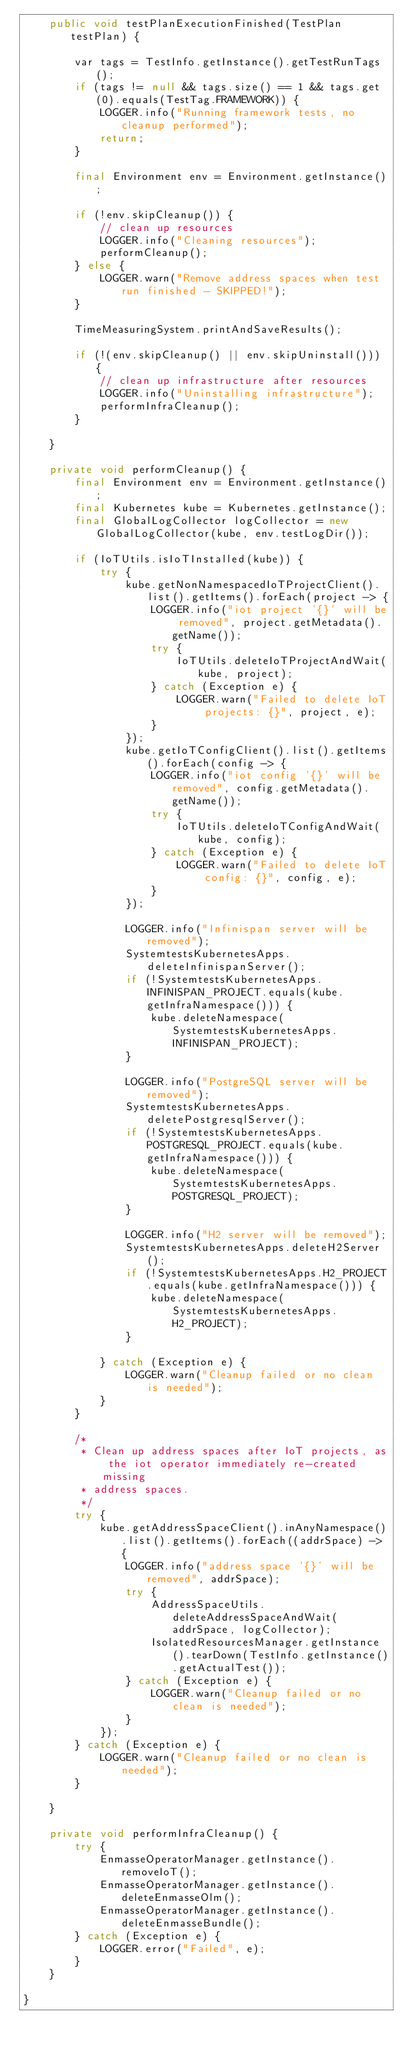<code> <loc_0><loc_0><loc_500><loc_500><_Java_>    public void testPlanExecutionFinished(TestPlan testPlan) {

        var tags = TestInfo.getInstance().getTestRunTags();
        if (tags != null && tags.size() == 1 && tags.get(0).equals(TestTag.FRAMEWORK)) {
            LOGGER.info("Running framework tests, no cleanup performed");
            return;
        }

        final Environment env = Environment.getInstance();

        if (!env.skipCleanup()) {
            // clean up resources
            LOGGER.info("Cleaning resources");
            performCleanup();
        } else {
            LOGGER.warn("Remove address spaces when test run finished - SKIPPED!");
        }

        TimeMeasuringSystem.printAndSaveResults();

        if (!(env.skipCleanup() || env.skipUninstall())) {
            // clean up infrastructure after resources
            LOGGER.info("Uninstalling infrastructure");
            performInfraCleanup();
        }

    }

    private void performCleanup() {
        final Environment env = Environment.getInstance();
        final Kubernetes kube = Kubernetes.getInstance();
        final GlobalLogCollector logCollector = new GlobalLogCollector(kube, env.testLogDir());

        if (IoTUtils.isIoTInstalled(kube)) {
            try {
                kube.getNonNamespacedIoTProjectClient().list().getItems().forEach(project -> {
                    LOGGER.info("iot project '{}' will be removed", project.getMetadata().getName());
                    try {
                        IoTUtils.deleteIoTProjectAndWait(kube, project);
                    } catch (Exception e) {
                        LOGGER.warn("Failed to delete IoT projects: {}", project, e);
                    }
                });
                kube.getIoTConfigClient().list().getItems().forEach(config -> {
                    LOGGER.info("iot config '{}' will be removed", config.getMetadata().getName());
                    try {
                        IoTUtils.deleteIoTConfigAndWait(kube, config);
                    } catch (Exception e) {
                        LOGGER.warn("Failed to delete IoT config: {}", config, e);
                    }
                });

                LOGGER.info("Infinispan server will be removed");
                SystemtestsKubernetesApps.deleteInfinispanServer();
                if (!SystemtestsKubernetesApps.INFINISPAN_PROJECT.equals(kube.getInfraNamespace())) {
                    kube.deleteNamespace(SystemtestsKubernetesApps.INFINISPAN_PROJECT);
                }

                LOGGER.info("PostgreSQL server will be removed");
                SystemtestsKubernetesApps.deletePostgresqlServer();
                if (!SystemtestsKubernetesApps.POSTGRESQL_PROJECT.equals(kube.getInfraNamespace())) {
                    kube.deleteNamespace(SystemtestsKubernetesApps.POSTGRESQL_PROJECT);
                }

                LOGGER.info("H2 server will be removed");
                SystemtestsKubernetesApps.deleteH2Server();
                if (!SystemtestsKubernetesApps.H2_PROJECT.equals(kube.getInfraNamespace())) {
                    kube.deleteNamespace(SystemtestsKubernetesApps.H2_PROJECT);
                }

            } catch (Exception e) {
                LOGGER.warn("Cleanup failed or no clean is needed");
            }
        }

        /*
         * Clean up address spaces after IoT projects, as the iot operator immediately re-created missing
         * address spaces.
         */
        try {
            kube.getAddressSpaceClient().inAnyNamespace().list().getItems().forEach((addrSpace) -> {
                LOGGER.info("address space '{}' will be removed", addrSpace);
                try {
                    AddressSpaceUtils.deleteAddressSpaceAndWait(addrSpace, logCollector);
                    IsolatedResourcesManager.getInstance().tearDown(TestInfo.getInstance().getActualTest());
                } catch (Exception e) {
                    LOGGER.warn("Cleanup failed or no clean is needed");
                }
            });
        } catch (Exception e) {
            LOGGER.warn("Cleanup failed or no clean is needed");
        }

    }

    private void performInfraCleanup() {
        try {
            EnmasseOperatorManager.getInstance().removeIoT();
            EnmasseOperatorManager.getInstance().deleteEnmasseOlm();
            EnmasseOperatorManager.getInstance().deleteEnmasseBundle();
        } catch (Exception e) {
            LOGGER.error("Failed", e);
        }
    }

}
</code> 